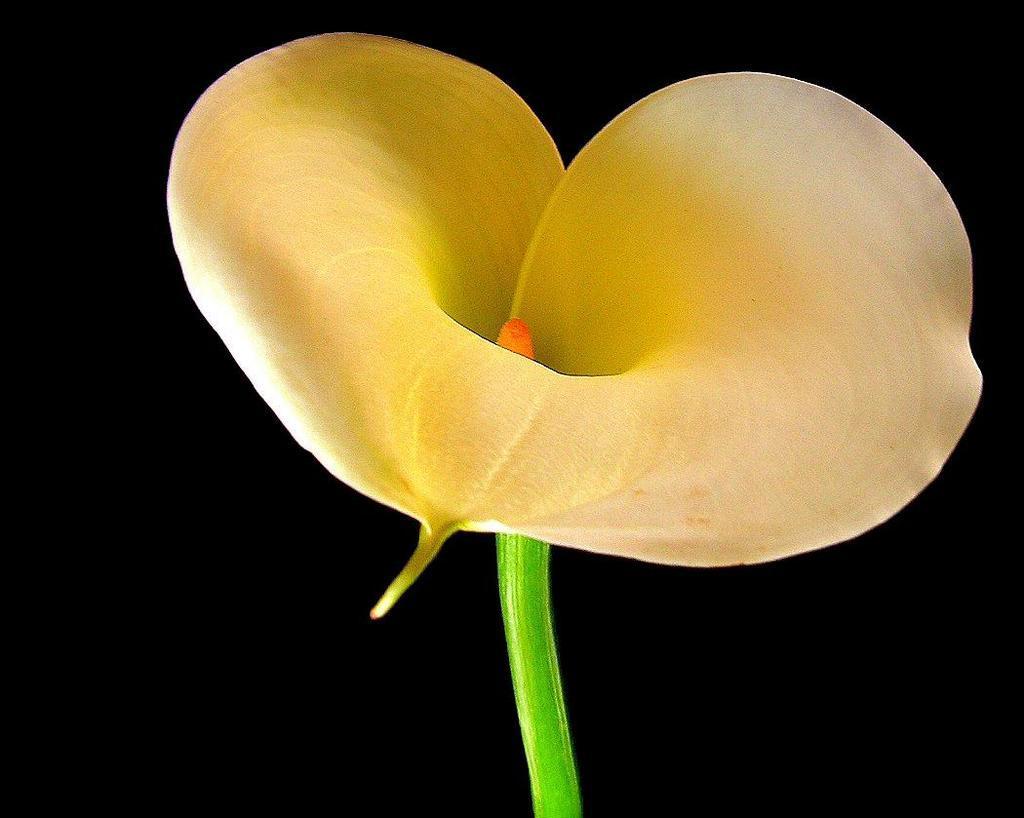How would you summarize this image in a sentence or two? In this image, we can see a flower on the dark background. 